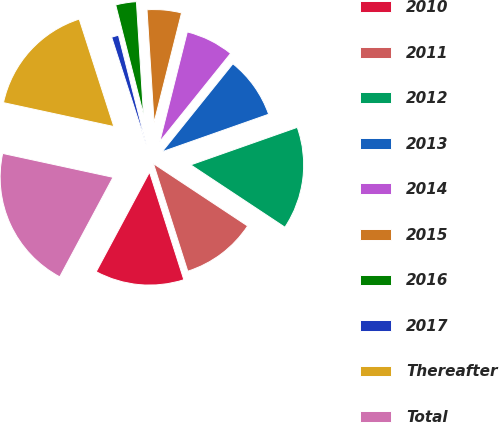Convert chart. <chart><loc_0><loc_0><loc_500><loc_500><pie_chart><fcel>2010<fcel>2011<fcel>2012<fcel>2013<fcel>2014<fcel>2015<fcel>2016<fcel>2017<fcel>Thereafter<fcel>Total<nl><fcel>12.74%<fcel>10.78%<fcel>14.7%<fcel>8.83%<fcel>6.87%<fcel>4.91%<fcel>2.96%<fcel>1.0%<fcel>16.65%<fcel>20.57%<nl></chart> 